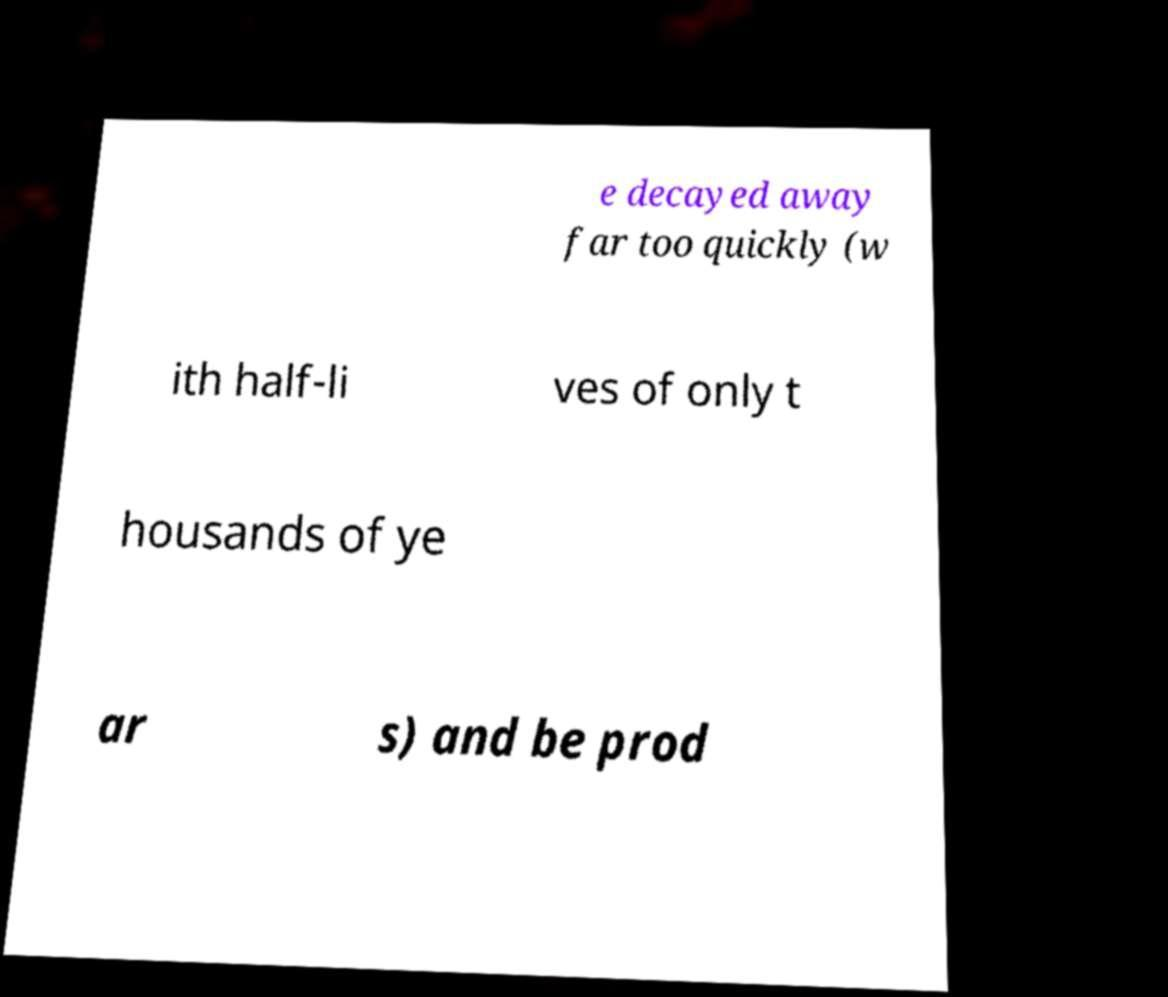For documentation purposes, I need the text within this image transcribed. Could you provide that? e decayed away far too quickly (w ith half-li ves of only t housands of ye ar s) and be prod 